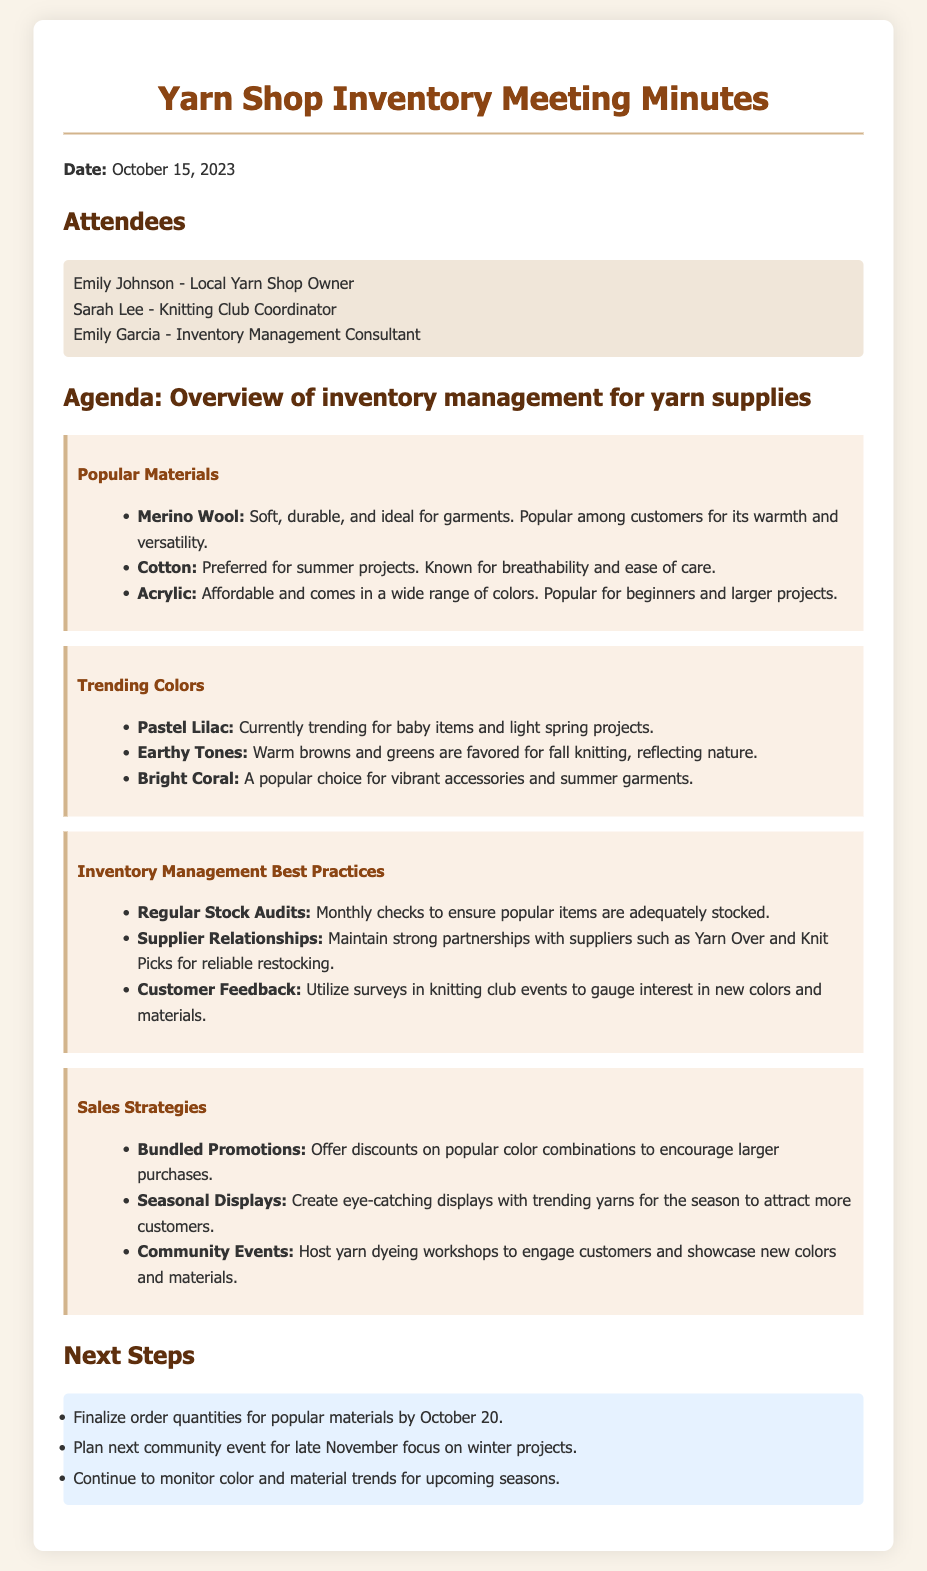What date was the meeting held? The date of the meeting is explicitly stated at the beginning of the document as October 15, 2023.
Answer: October 15, 2023 Who is the Local Yarn Shop Owner? The document lists Emily Johnson as the Local Yarn Shop Owner among the attendees.
Answer: Emily Johnson What material is preferred for summer projects? The document specifies Cotton as the material preferred for summer projects.
Answer: Cotton Which color is currently trending for baby items? Pastel Lilac is highlighted in the document as currently trending for baby items.
Answer: Pastel Lilac What best practice involves monthly checks? Regular Stock Audits are mentioned as a best practice that involves monthly checks.
Answer: Regular Stock Audits How many steps are outlined for next actions? The document lists three next steps in the Next Steps section.
Answer: Three What type of promotions are suggested to encourage larger purchases? The document suggests Bundled Promotions as a strategy to encourage larger purchases.
Answer: Bundled Promotions What is one way to gauge interest in new colors? Customer Feedback through surveys at knitting club events is suggested in the document.
Answer: Customer Feedback What is the focus for the next community event? The next community event is planned to focus on winter projects as stated in the document.
Answer: Winter projects 